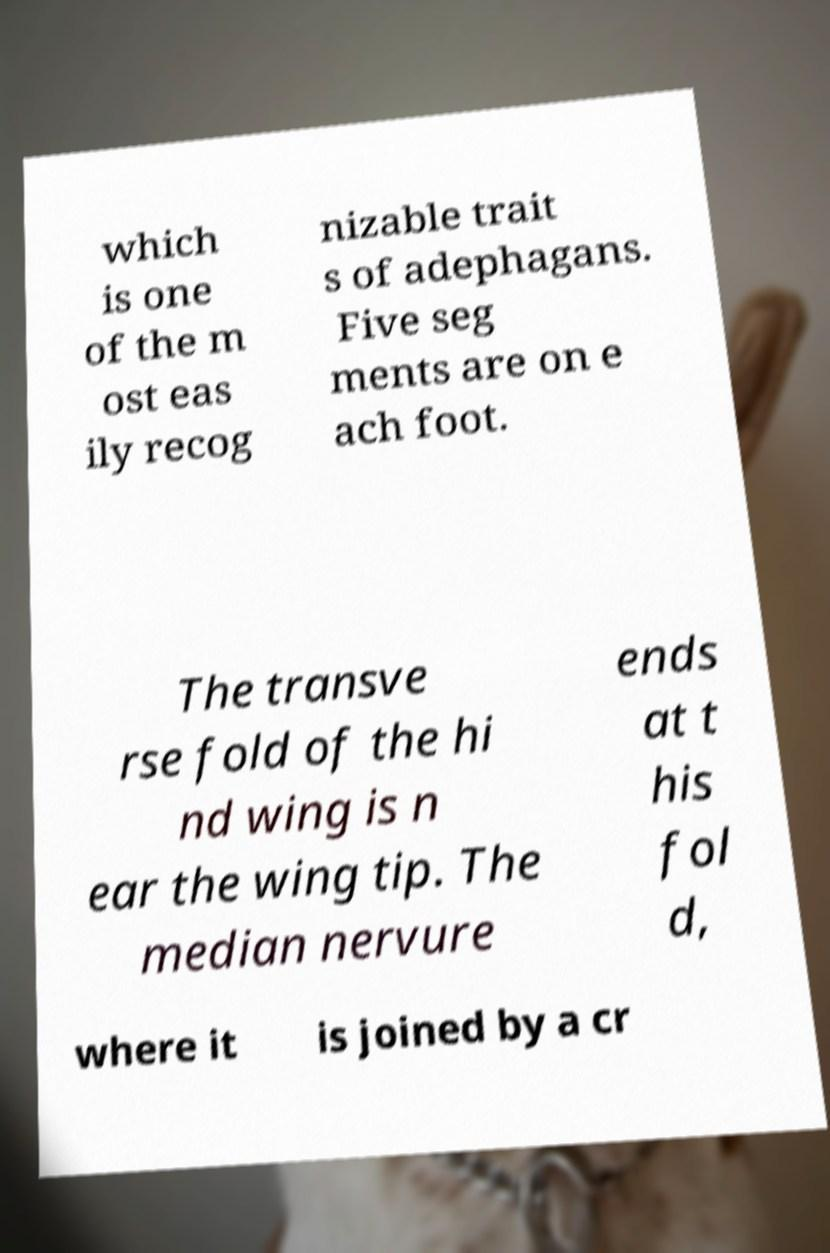Can you read and provide the text displayed in the image?This photo seems to have some interesting text. Can you extract and type it out for me? which is one of the m ost eas ily recog nizable trait s of adephagans. Five seg ments are on e ach foot. The transve rse fold of the hi nd wing is n ear the wing tip. The median nervure ends at t his fol d, where it is joined by a cr 